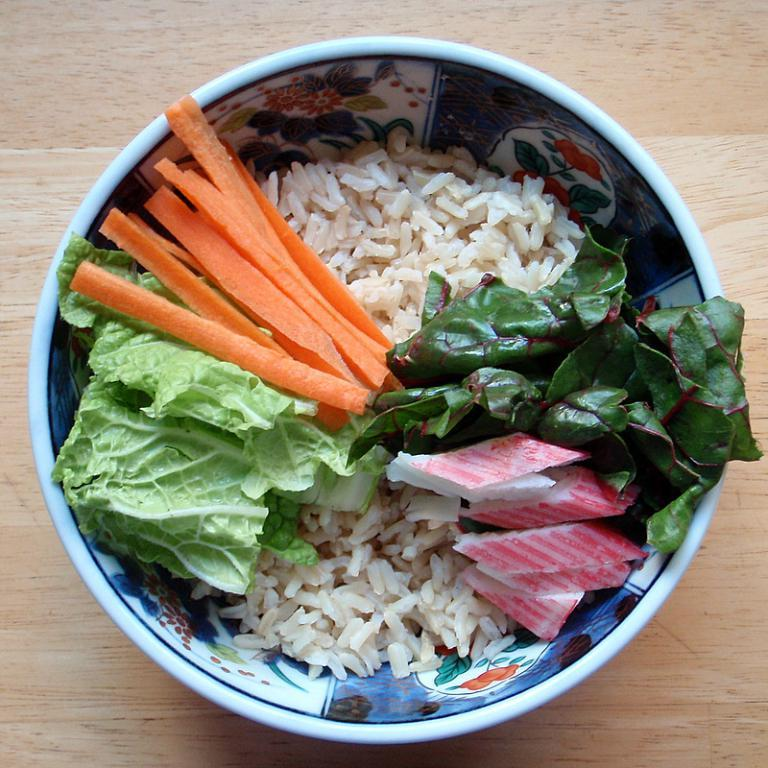What is in the bowl that is visible in the image? There is a bowl in the image. What is contained within the bowl? The bowl contains rice, leafy vegetables, and carrot slices. What is the rate of the neck's experience in the image? There is no neck or experience present in the image; it only features a bowl containing rice, leafy vegetables, and carrot slices. 